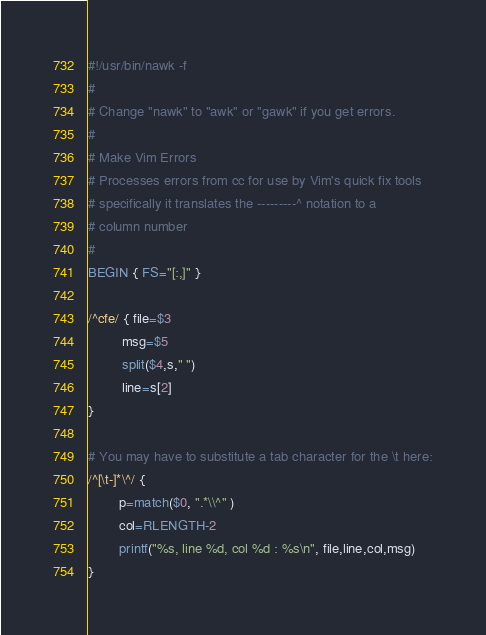<code> <loc_0><loc_0><loc_500><loc_500><_Awk_>#!/usr/bin/nawk -f
#
# Change "nawk" to "awk" or "gawk" if you get errors.
#
# Make Vim Errors
# Processes errors from cc for use by Vim's quick fix tools
# specifically it translates the ---------^ notation to a
# column number
#
BEGIN { FS="[:,]" }

/^cfe/ { file=$3
         msg=$5
         split($4,s," ")
         line=s[2]
}

# You may have to substitute a tab character for the \t here:
/^[\t-]*\^/ {
        p=match($0, ".*\\^" )
        col=RLENGTH-2
        printf("%s, line %d, col %d : %s\n", file,line,col,msg)
}
</code> 